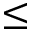<formula> <loc_0><loc_0><loc_500><loc_500>\leq</formula> 